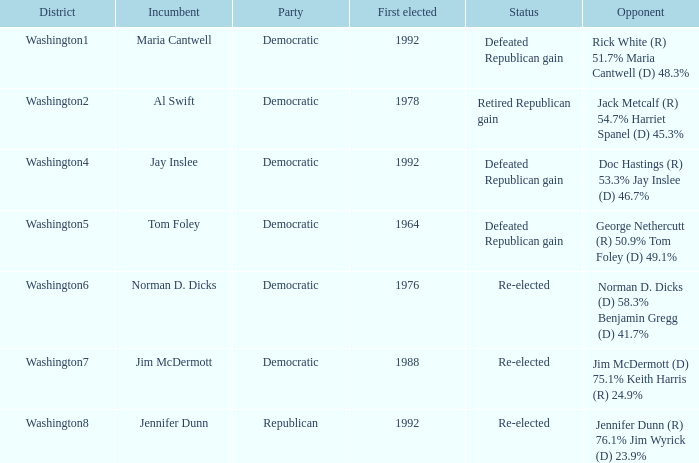What year did incumbent jim mcdermott win his first election? 1988.0. 